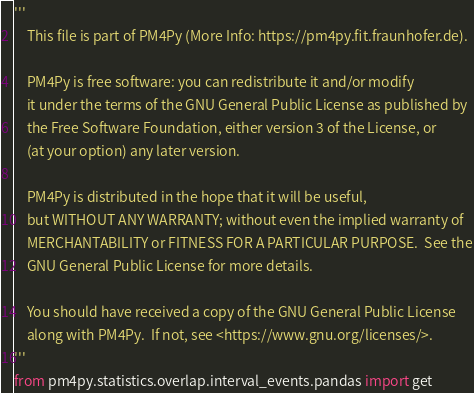<code> <loc_0><loc_0><loc_500><loc_500><_Python_>'''
    This file is part of PM4Py (More Info: https://pm4py.fit.fraunhofer.de).

    PM4Py is free software: you can redistribute it and/or modify
    it under the terms of the GNU General Public License as published by
    the Free Software Foundation, either version 3 of the License, or
    (at your option) any later version.

    PM4Py is distributed in the hope that it will be useful,
    but WITHOUT ANY WARRANTY; without even the implied warranty of
    MERCHANTABILITY or FITNESS FOR A PARTICULAR PURPOSE.  See the
    GNU General Public License for more details.

    You should have received a copy of the GNU General Public License
    along with PM4Py.  If not, see <https://www.gnu.org/licenses/>.
'''
from pm4py.statistics.overlap.interval_events.pandas import get
</code> 